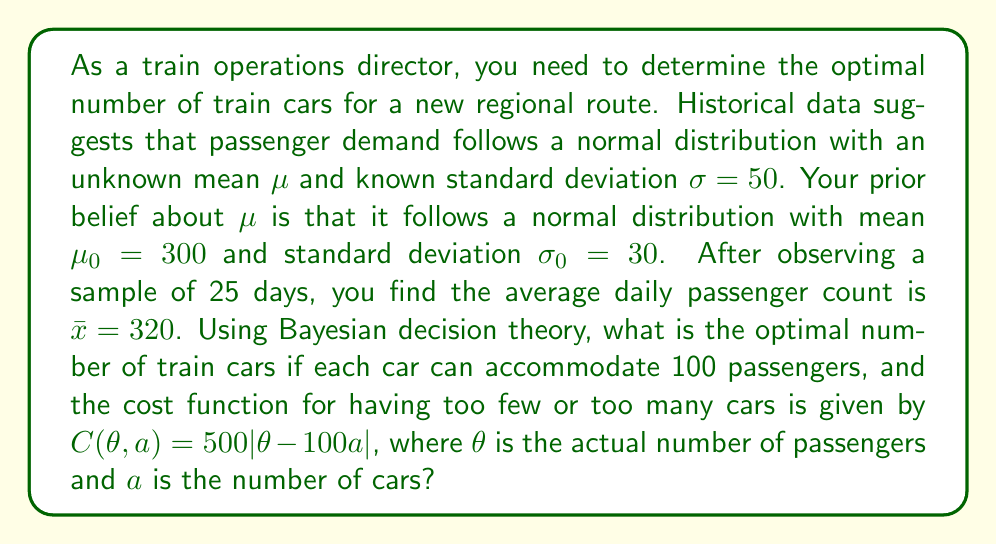Provide a solution to this math problem. To solve this problem, we'll follow these steps:

1) First, we need to update our belief about $\mu$ using Bayesian inference.

2) Then, we'll use the posterior distribution to find the optimal number of cars.

Step 1: Bayesian Update

The posterior distribution for $\mu$ is also normal, with parameters:

$$\mu_n = \frac{\frac{n}{\sigma^2}\bar{x} + \frac{1}{\sigma_0^2}\mu_0}{\frac{n}{\sigma^2} + \frac{1}{\sigma_0^2}}$$

$$\frac{1}{\sigma_n^2} = \frac{n}{\sigma^2} + \frac{1}{\sigma_0^2}$$

Where $n = 25$ (sample size), $\bar{x} = 320$ (sample mean), $\sigma = 50$ (known standard deviation), $\mu_0 = 300$ (prior mean), and $\sigma_0 = 30$ (prior standard deviation).

Plugging in the values:

$$\mu_n = \frac{\frac{25}{50^2}320 + \frac{1}{30^2}300}{\frac{25}{50^2} + \frac{1}{30^2}} \approx 317.8$$

$$\frac{1}{\sigma_n^2} = \frac{25}{50^2} + \frac{1}{30^2} \approx 0.0211$$

$$\sigma_n \approx 6.89$$

Step 2: Optimal Decision

The expected cost for choosing $a$ cars is:

$$E[C(\theta, a)] = 500 \int_{-\infty}^{\infty} |\theta - 100a| f(\theta) d\theta$$

where $f(\theta)$ is the posterior normal distribution with mean $\mu_n$ and standard deviation $\sigma_n$.

The optimal decision $a^*$ minimizes this expected cost. For the normal distribution, this occurs when:

$$P(\theta \leq 100a^*) = \frac{500}{1000} = 0.5$$

This means the optimal number of cars $a^*$ is such that $100a^*$ is the median of the posterior distribution, which for a normal distribution is equal to the mean.

Therefore:

$$100a^* = \mu_n \approx 317.8$$

$$a^* \approx 3.178$$

Since we can only use whole numbers of cars, we round to the nearest integer.
Answer: The optimal number of train cars is 3. 